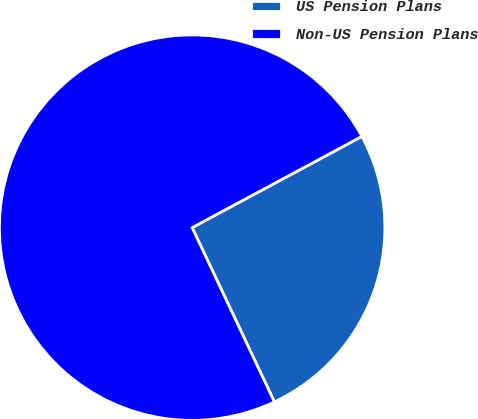<chart> <loc_0><loc_0><loc_500><loc_500><pie_chart><fcel>US Pension Plans<fcel>Non-US Pension Plans<nl><fcel>25.83%<fcel>74.17%<nl></chart> 